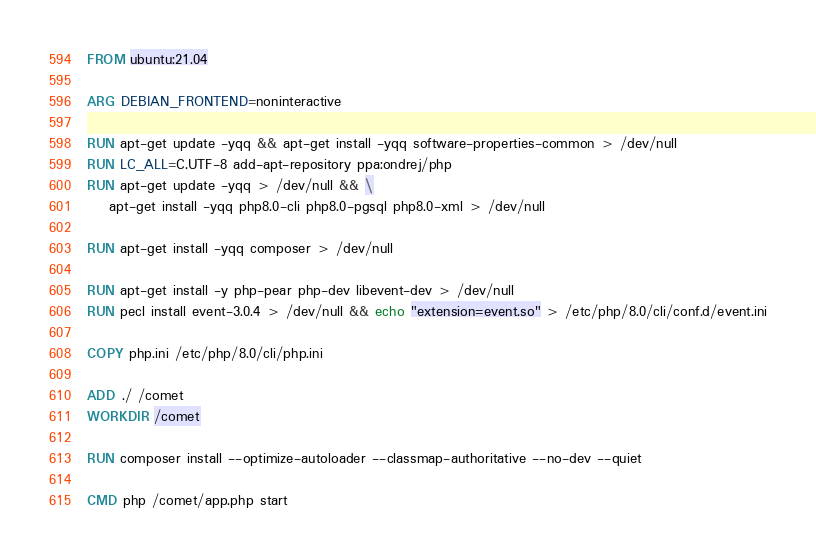<code> <loc_0><loc_0><loc_500><loc_500><_Dockerfile_>FROM ubuntu:21.04

ARG DEBIAN_FRONTEND=noninteractive

RUN apt-get update -yqq && apt-get install -yqq software-properties-common > /dev/null
RUN LC_ALL=C.UTF-8 add-apt-repository ppa:ondrej/php
RUN apt-get update -yqq > /dev/null && \
    apt-get install -yqq php8.0-cli php8.0-pgsql php8.0-xml > /dev/null

RUN apt-get install -yqq composer > /dev/null

RUN apt-get install -y php-pear php-dev libevent-dev > /dev/null
RUN pecl install event-3.0.4 > /dev/null && echo "extension=event.so" > /etc/php/8.0/cli/conf.d/event.ini

COPY php.ini /etc/php/8.0/cli/php.ini

ADD ./ /comet
WORKDIR /comet

RUN composer install --optimize-autoloader --classmap-authoritative --no-dev --quiet

CMD php /comet/app.php start
</code> 